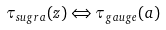Convert formula to latex. <formula><loc_0><loc_0><loc_500><loc_500>\tau _ { s u g r a } ( z ) \Leftrightarrow \tau _ { g a u g e } ( a )</formula> 